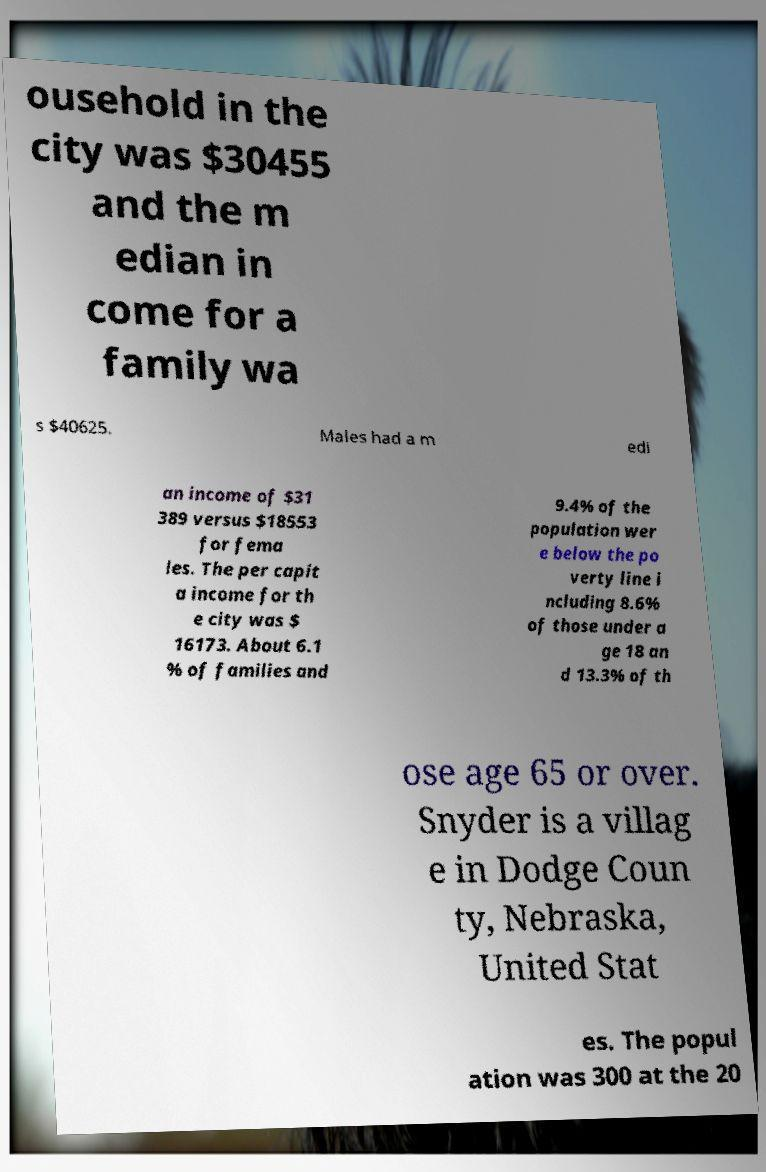Please read and relay the text visible in this image. What does it say? ousehold in the city was $30455 and the m edian in come for a family wa s $40625. Males had a m edi an income of $31 389 versus $18553 for fema les. The per capit a income for th e city was $ 16173. About 6.1 % of families and 9.4% of the population wer e below the po verty line i ncluding 8.6% of those under a ge 18 an d 13.3% of th ose age 65 or over. Snyder is a villag e in Dodge Coun ty, Nebraska, United Stat es. The popul ation was 300 at the 20 